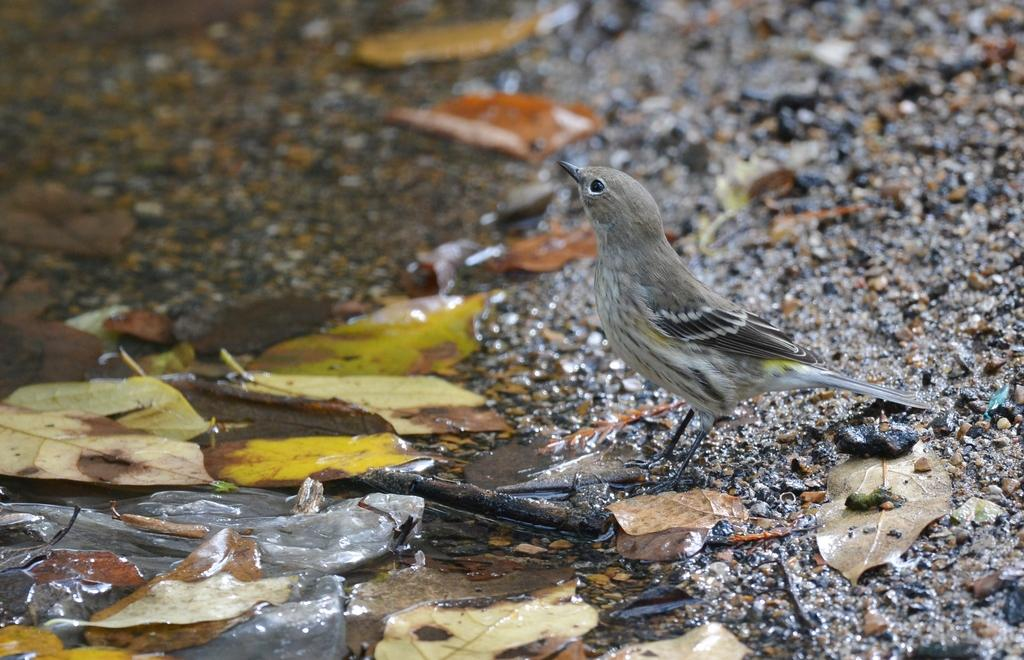What type of animal can be seen in the image? There is a bird in the image. What natural elements are present in the image? There are leaves and water visible in the image. How many jellyfish can be seen swimming in the water in the image? There are no jellyfish present in the image; it features a bird and natural elements like leaves and water. Is there a boy holding sticks in the image? There is no boy or sticks present in the image. 